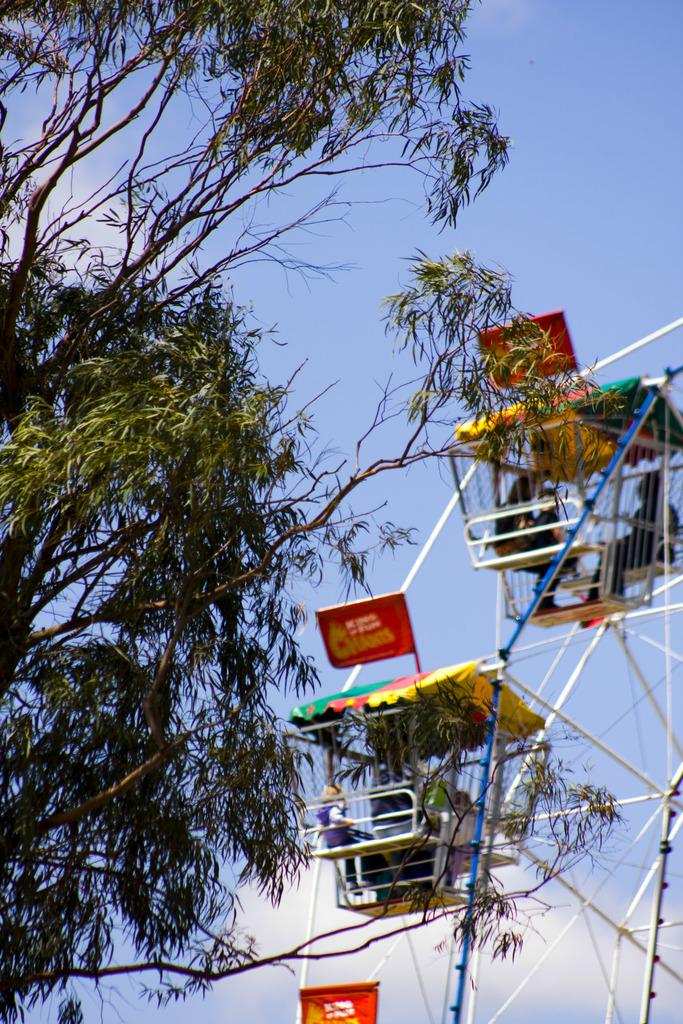What is the main feature in the image? There is a giant wheel in the image. Are there any people present in the image? Yes, there are people in the image. What can be seen in the background of the image? There are trees and the sky visible in the background of the image. How many grapes are being delivered in a parcel in the image? There is no parcel or grapes present in the image. What type of fruit is being smashed by the giant wheel in the image? There is no fruit being smashed by the giant wheel in the image; it is a stationary structure. 